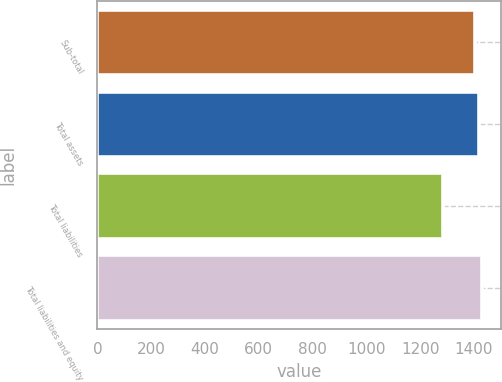Convert chart to OTSL. <chart><loc_0><loc_0><loc_500><loc_500><bar_chart><fcel>Sub-total<fcel>Total assets<fcel>Total liabilities<fcel>Total liabilities and equity<nl><fcel>1405<fcel>1417<fcel>1285<fcel>1429<nl></chart> 